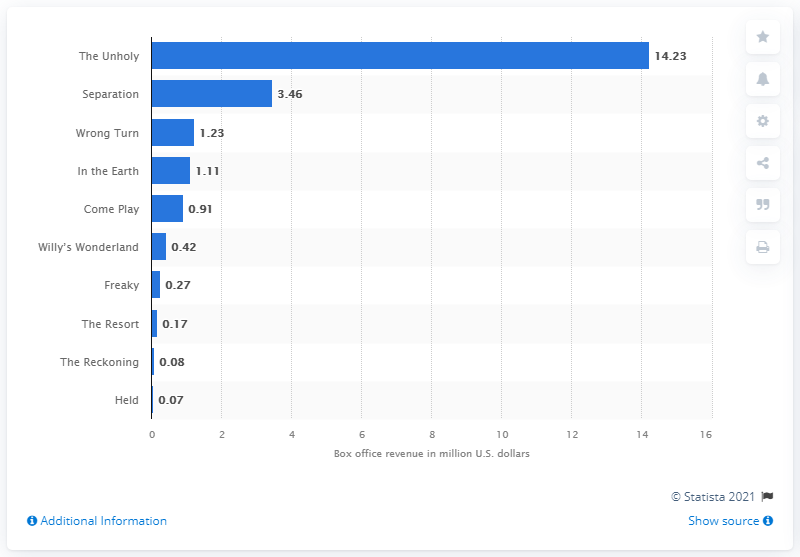Highlight a few significant elements in this photo. The highest grossing horror movie in the U.S. in May 2021 was "The Unholy. The North American box office generated $14.23 for the movie 'The Unholy.' 